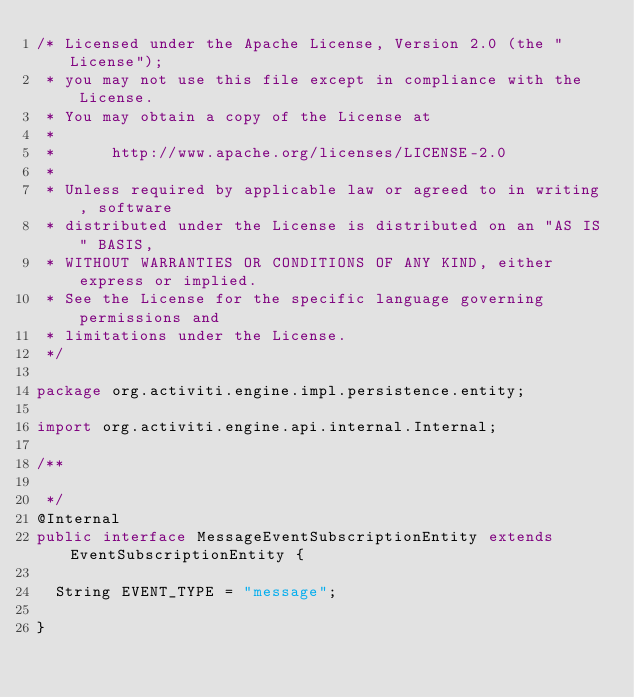Convert code to text. <code><loc_0><loc_0><loc_500><loc_500><_Java_>/* Licensed under the Apache License, Version 2.0 (the "License");
 * you may not use this file except in compliance with the License.
 * You may obtain a copy of the License at
 * 
 *      http://www.apache.org/licenses/LICENSE-2.0
 * 
 * Unless required by applicable law or agreed to in writing, software
 * distributed under the License is distributed on an "AS IS" BASIS,
 * WITHOUT WARRANTIES OR CONDITIONS OF ANY KIND, either express or implied.
 * See the License for the specific language governing permissions and
 * limitations under the License.
 */

package org.activiti.engine.impl.persistence.entity;

import org.activiti.engine.api.internal.Internal;

/**

 */
@Internal
public interface MessageEventSubscriptionEntity extends EventSubscriptionEntity {
  
  String EVENT_TYPE = "message";

}
</code> 